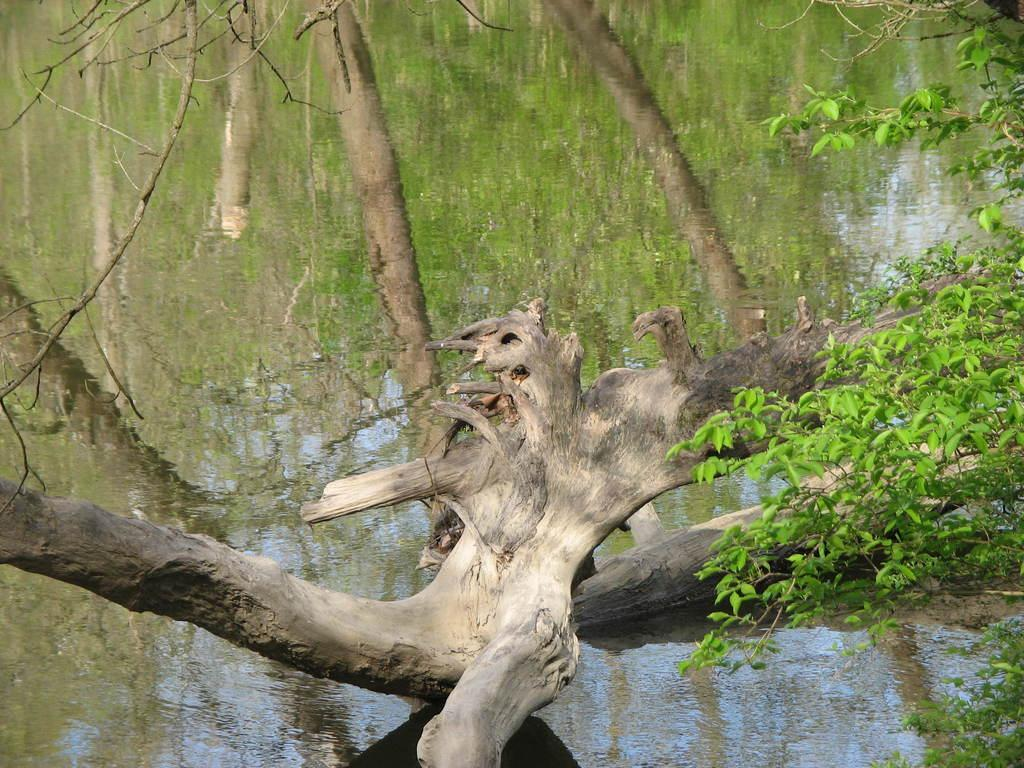What is located in the foreground of the image? There is a tree trunk in the foreground of the image. What can be seen on the right side of the image? There is a tree on the right side of the image. What is visible in the background of the image? There is water visible in the background of the image. What is reflected in the water? There is a reflection of trees in the water. What type of cable can be seen hanging from the tree in the image? There is no cable hanging from the tree in the image; it only features a tree trunk in the foreground and a tree on the right side. What time of day does the image depict? The time of day cannot be determined from the image, as there are no specific clues or indicators of the time. 